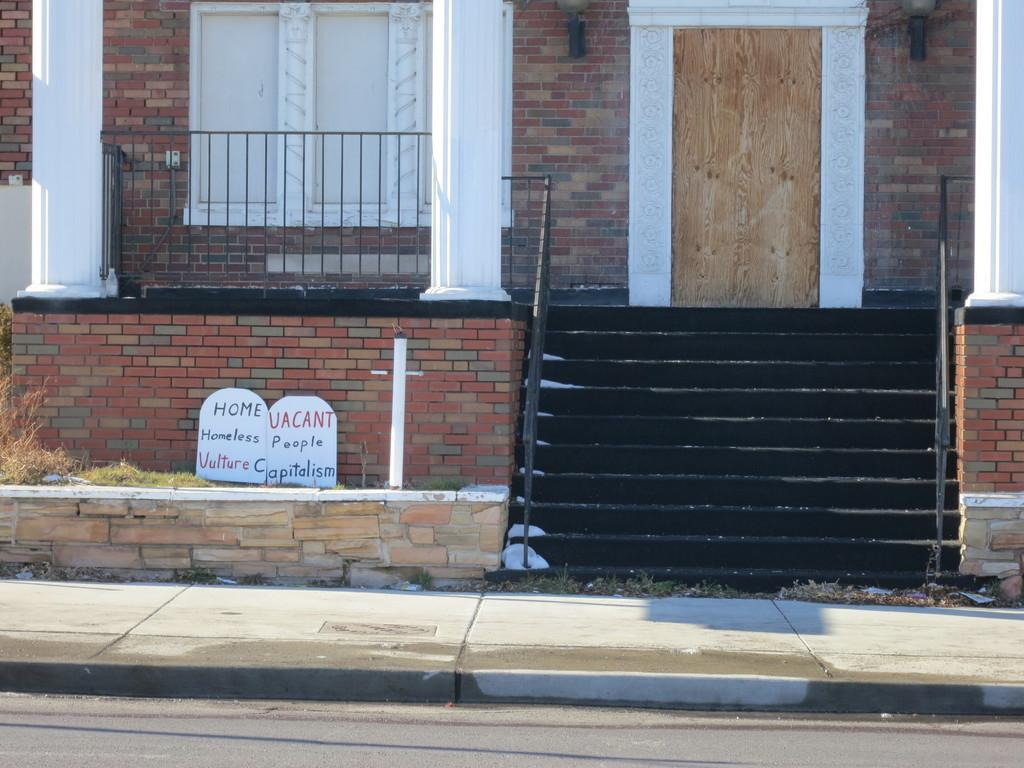How many white boards are visible in the image? There are two white boards in the image. What architectural feature can be seen in the image? There are stairs in the image. What safety feature is present in the image? There is a railing in the image. What is the color of the building in the image? The building is in brown color. What can be seen through the windows in the building? The presence of windows in the building suggests that there might be a view or other objects visible through them, but this cannot be definitively determined from the provided facts. Can you tell me how many times the grandmother sneezes in the image? There is no grandmother or sneezing present in the image. What type of things are visible in the image? The provided facts do not mention any "things" in the image, so it is not possible to answer this question definitively. 